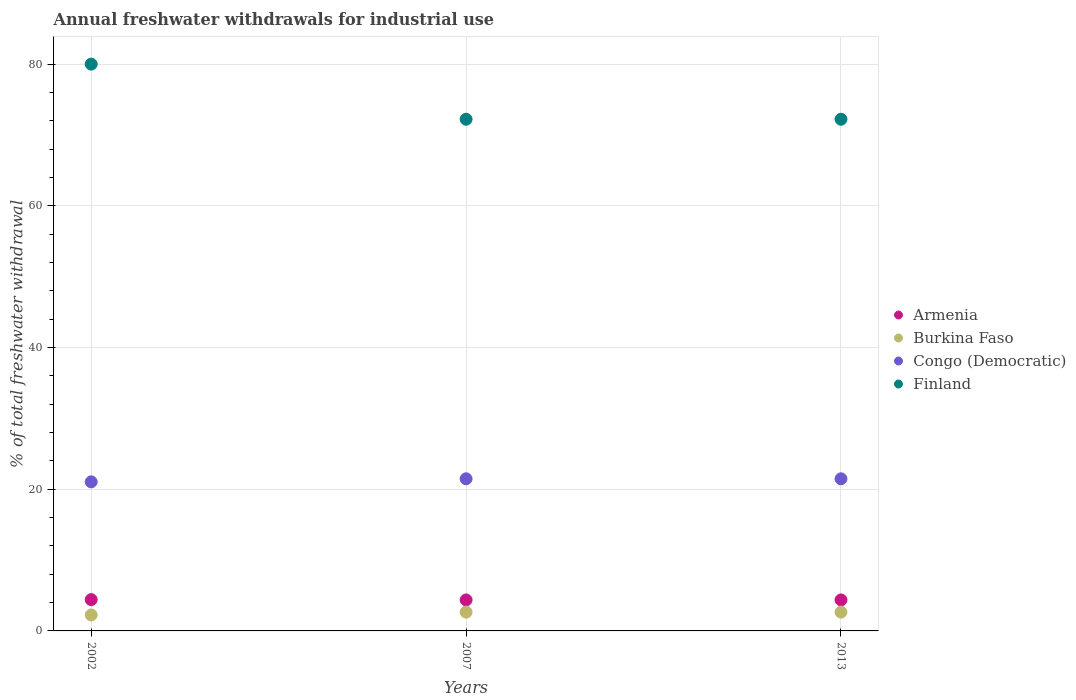How many different coloured dotlines are there?
Your answer should be very brief. 4. Is the number of dotlines equal to the number of legend labels?
Your answer should be very brief. Yes. What is the total annual withdrawals from freshwater in Burkina Faso in 2013?
Make the answer very short. 2.65. Across all years, what is the minimum total annual withdrawals from freshwater in Burkina Faso?
Give a very brief answer. 2.25. In which year was the total annual withdrawals from freshwater in Congo (Democratic) minimum?
Provide a short and direct response. 2002. What is the total total annual withdrawals from freshwater in Finland in the graph?
Your answer should be compact. 224.44. What is the difference between the total annual withdrawals from freshwater in Burkina Faso in 2002 and that in 2007?
Offer a very short reply. -0.4. What is the difference between the total annual withdrawals from freshwater in Burkina Faso in 2002 and the total annual withdrawals from freshwater in Congo (Democratic) in 2013?
Provide a short and direct response. -19.22. What is the average total annual withdrawals from freshwater in Armenia per year?
Keep it short and to the point. 4.39. In the year 2013, what is the difference between the total annual withdrawals from freshwater in Armenia and total annual withdrawals from freshwater in Finland?
Offer a terse response. -67.85. In how many years, is the total annual withdrawals from freshwater in Burkina Faso greater than 12 %?
Keep it short and to the point. 0. What is the ratio of the total annual withdrawals from freshwater in Finland in 2002 to that in 2007?
Provide a short and direct response. 1.11. Is the total annual withdrawals from freshwater in Congo (Democratic) in 2002 less than that in 2013?
Keep it short and to the point. Yes. Is the difference between the total annual withdrawals from freshwater in Armenia in 2002 and 2013 greater than the difference between the total annual withdrawals from freshwater in Finland in 2002 and 2013?
Provide a succinct answer. No. What is the difference between the highest and the second highest total annual withdrawals from freshwater in Armenia?
Offer a very short reply. 0.05. What is the difference between the highest and the lowest total annual withdrawals from freshwater in Congo (Democratic)?
Offer a very short reply. 0.43. Does the total annual withdrawals from freshwater in Armenia monotonically increase over the years?
Offer a terse response. No. Is the total annual withdrawals from freshwater in Armenia strictly greater than the total annual withdrawals from freshwater in Burkina Faso over the years?
Provide a succinct answer. Yes. How many dotlines are there?
Give a very brief answer. 4. How many years are there in the graph?
Provide a succinct answer. 3. Does the graph contain grids?
Offer a very short reply. Yes. Where does the legend appear in the graph?
Provide a succinct answer. Center right. How are the legend labels stacked?
Provide a succinct answer. Vertical. What is the title of the graph?
Make the answer very short. Annual freshwater withdrawals for industrial use. What is the label or title of the Y-axis?
Provide a short and direct response. % of total freshwater withdrawal. What is the % of total freshwater withdrawal of Armenia in 2002?
Ensure brevity in your answer.  4.42. What is the % of total freshwater withdrawal of Burkina Faso in 2002?
Make the answer very short. 2.25. What is the % of total freshwater withdrawal in Congo (Democratic) in 2002?
Provide a succinct answer. 21.04. What is the % of total freshwater withdrawal of Finland in 2002?
Ensure brevity in your answer.  80. What is the % of total freshwater withdrawal in Armenia in 2007?
Make the answer very short. 4.37. What is the % of total freshwater withdrawal in Burkina Faso in 2007?
Ensure brevity in your answer.  2.65. What is the % of total freshwater withdrawal in Congo (Democratic) in 2007?
Provide a succinct answer. 21.47. What is the % of total freshwater withdrawal in Finland in 2007?
Keep it short and to the point. 72.22. What is the % of total freshwater withdrawal of Armenia in 2013?
Keep it short and to the point. 4.37. What is the % of total freshwater withdrawal of Burkina Faso in 2013?
Your answer should be very brief. 2.65. What is the % of total freshwater withdrawal of Congo (Democratic) in 2013?
Your answer should be very brief. 21.47. What is the % of total freshwater withdrawal in Finland in 2013?
Offer a very short reply. 72.22. Across all years, what is the maximum % of total freshwater withdrawal of Armenia?
Ensure brevity in your answer.  4.42. Across all years, what is the maximum % of total freshwater withdrawal in Burkina Faso?
Make the answer very short. 2.65. Across all years, what is the maximum % of total freshwater withdrawal of Congo (Democratic)?
Keep it short and to the point. 21.47. Across all years, what is the minimum % of total freshwater withdrawal in Armenia?
Your answer should be compact. 4.37. Across all years, what is the minimum % of total freshwater withdrawal of Burkina Faso?
Provide a short and direct response. 2.25. Across all years, what is the minimum % of total freshwater withdrawal in Congo (Democratic)?
Your answer should be compact. 21.04. Across all years, what is the minimum % of total freshwater withdrawal of Finland?
Your answer should be very brief. 72.22. What is the total % of total freshwater withdrawal in Armenia in the graph?
Keep it short and to the point. 13.17. What is the total % of total freshwater withdrawal of Burkina Faso in the graph?
Offer a very short reply. 7.56. What is the total % of total freshwater withdrawal of Congo (Democratic) in the graph?
Ensure brevity in your answer.  63.98. What is the total % of total freshwater withdrawal in Finland in the graph?
Ensure brevity in your answer.  224.44. What is the difference between the % of total freshwater withdrawal of Armenia in 2002 and that in 2007?
Your response must be concise. 0.05. What is the difference between the % of total freshwater withdrawal of Burkina Faso in 2002 and that in 2007?
Ensure brevity in your answer.  -0.4. What is the difference between the % of total freshwater withdrawal in Congo (Democratic) in 2002 and that in 2007?
Offer a terse response. -0.43. What is the difference between the % of total freshwater withdrawal of Finland in 2002 and that in 2007?
Provide a succinct answer. 7.78. What is the difference between the % of total freshwater withdrawal in Armenia in 2002 and that in 2013?
Your answer should be very brief. 0.05. What is the difference between the % of total freshwater withdrawal in Burkina Faso in 2002 and that in 2013?
Your answer should be very brief. -0.4. What is the difference between the % of total freshwater withdrawal of Congo (Democratic) in 2002 and that in 2013?
Keep it short and to the point. -0.43. What is the difference between the % of total freshwater withdrawal in Finland in 2002 and that in 2013?
Give a very brief answer. 7.78. What is the difference between the % of total freshwater withdrawal in Armenia in 2007 and that in 2013?
Offer a very short reply. 0. What is the difference between the % of total freshwater withdrawal of Burkina Faso in 2007 and that in 2013?
Give a very brief answer. 0. What is the difference between the % of total freshwater withdrawal in Armenia in 2002 and the % of total freshwater withdrawal in Burkina Faso in 2007?
Your response must be concise. 1.77. What is the difference between the % of total freshwater withdrawal of Armenia in 2002 and the % of total freshwater withdrawal of Congo (Democratic) in 2007?
Keep it short and to the point. -17.05. What is the difference between the % of total freshwater withdrawal in Armenia in 2002 and the % of total freshwater withdrawal in Finland in 2007?
Ensure brevity in your answer.  -67.8. What is the difference between the % of total freshwater withdrawal of Burkina Faso in 2002 and the % of total freshwater withdrawal of Congo (Democratic) in 2007?
Offer a very short reply. -19.22. What is the difference between the % of total freshwater withdrawal of Burkina Faso in 2002 and the % of total freshwater withdrawal of Finland in 2007?
Provide a succinct answer. -69.97. What is the difference between the % of total freshwater withdrawal in Congo (Democratic) in 2002 and the % of total freshwater withdrawal in Finland in 2007?
Your answer should be very brief. -51.18. What is the difference between the % of total freshwater withdrawal of Armenia in 2002 and the % of total freshwater withdrawal of Burkina Faso in 2013?
Provide a succinct answer. 1.77. What is the difference between the % of total freshwater withdrawal of Armenia in 2002 and the % of total freshwater withdrawal of Congo (Democratic) in 2013?
Your answer should be compact. -17.05. What is the difference between the % of total freshwater withdrawal of Armenia in 2002 and the % of total freshwater withdrawal of Finland in 2013?
Keep it short and to the point. -67.8. What is the difference between the % of total freshwater withdrawal in Burkina Faso in 2002 and the % of total freshwater withdrawal in Congo (Democratic) in 2013?
Provide a succinct answer. -19.22. What is the difference between the % of total freshwater withdrawal in Burkina Faso in 2002 and the % of total freshwater withdrawal in Finland in 2013?
Provide a succinct answer. -69.97. What is the difference between the % of total freshwater withdrawal in Congo (Democratic) in 2002 and the % of total freshwater withdrawal in Finland in 2013?
Give a very brief answer. -51.18. What is the difference between the % of total freshwater withdrawal in Armenia in 2007 and the % of total freshwater withdrawal in Burkina Faso in 2013?
Ensure brevity in your answer.  1.72. What is the difference between the % of total freshwater withdrawal of Armenia in 2007 and the % of total freshwater withdrawal of Congo (Democratic) in 2013?
Offer a terse response. -17.1. What is the difference between the % of total freshwater withdrawal of Armenia in 2007 and the % of total freshwater withdrawal of Finland in 2013?
Ensure brevity in your answer.  -67.85. What is the difference between the % of total freshwater withdrawal in Burkina Faso in 2007 and the % of total freshwater withdrawal in Congo (Democratic) in 2013?
Offer a terse response. -18.82. What is the difference between the % of total freshwater withdrawal in Burkina Faso in 2007 and the % of total freshwater withdrawal in Finland in 2013?
Give a very brief answer. -69.57. What is the difference between the % of total freshwater withdrawal of Congo (Democratic) in 2007 and the % of total freshwater withdrawal of Finland in 2013?
Your response must be concise. -50.75. What is the average % of total freshwater withdrawal in Armenia per year?
Provide a succinct answer. 4.39. What is the average % of total freshwater withdrawal of Burkina Faso per year?
Your response must be concise. 2.52. What is the average % of total freshwater withdrawal of Congo (Democratic) per year?
Ensure brevity in your answer.  21.33. What is the average % of total freshwater withdrawal of Finland per year?
Offer a very short reply. 74.81. In the year 2002, what is the difference between the % of total freshwater withdrawal of Armenia and % of total freshwater withdrawal of Burkina Faso?
Provide a succinct answer. 2.17. In the year 2002, what is the difference between the % of total freshwater withdrawal in Armenia and % of total freshwater withdrawal in Congo (Democratic)?
Your answer should be compact. -16.62. In the year 2002, what is the difference between the % of total freshwater withdrawal in Armenia and % of total freshwater withdrawal in Finland?
Your answer should be very brief. -75.58. In the year 2002, what is the difference between the % of total freshwater withdrawal in Burkina Faso and % of total freshwater withdrawal in Congo (Democratic)?
Provide a succinct answer. -18.79. In the year 2002, what is the difference between the % of total freshwater withdrawal of Burkina Faso and % of total freshwater withdrawal of Finland?
Your answer should be very brief. -77.75. In the year 2002, what is the difference between the % of total freshwater withdrawal of Congo (Democratic) and % of total freshwater withdrawal of Finland?
Provide a succinct answer. -58.96. In the year 2007, what is the difference between the % of total freshwater withdrawal in Armenia and % of total freshwater withdrawal in Burkina Faso?
Provide a short and direct response. 1.72. In the year 2007, what is the difference between the % of total freshwater withdrawal of Armenia and % of total freshwater withdrawal of Congo (Democratic)?
Provide a succinct answer. -17.1. In the year 2007, what is the difference between the % of total freshwater withdrawal of Armenia and % of total freshwater withdrawal of Finland?
Ensure brevity in your answer.  -67.85. In the year 2007, what is the difference between the % of total freshwater withdrawal of Burkina Faso and % of total freshwater withdrawal of Congo (Democratic)?
Offer a very short reply. -18.82. In the year 2007, what is the difference between the % of total freshwater withdrawal in Burkina Faso and % of total freshwater withdrawal in Finland?
Offer a terse response. -69.57. In the year 2007, what is the difference between the % of total freshwater withdrawal in Congo (Democratic) and % of total freshwater withdrawal in Finland?
Make the answer very short. -50.75. In the year 2013, what is the difference between the % of total freshwater withdrawal of Armenia and % of total freshwater withdrawal of Burkina Faso?
Provide a succinct answer. 1.72. In the year 2013, what is the difference between the % of total freshwater withdrawal in Armenia and % of total freshwater withdrawal in Congo (Democratic)?
Your answer should be compact. -17.1. In the year 2013, what is the difference between the % of total freshwater withdrawal of Armenia and % of total freshwater withdrawal of Finland?
Offer a very short reply. -67.85. In the year 2013, what is the difference between the % of total freshwater withdrawal of Burkina Faso and % of total freshwater withdrawal of Congo (Democratic)?
Ensure brevity in your answer.  -18.82. In the year 2013, what is the difference between the % of total freshwater withdrawal of Burkina Faso and % of total freshwater withdrawal of Finland?
Your answer should be very brief. -69.57. In the year 2013, what is the difference between the % of total freshwater withdrawal of Congo (Democratic) and % of total freshwater withdrawal of Finland?
Offer a terse response. -50.75. What is the ratio of the % of total freshwater withdrawal in Armenia in 2002 to that in 2007?
Offer a very short reply. 1.01. What is the ratio of the % of total freshwater withdrawal of Burkina Faso in 2002 to that in 2007?
Keep it short and to the point. 0.85. What is the ratio of the % of total freshwater withdrawal in Congo (Democratic) in 2002 to that in 2007?
Provide a short and direct response. 0.98. What is the ratio of the % of total freshwater withdrawal in Finland in 2002 to that in 2007?
Provide a short and direct response. 1.11. What is the ratio of the % of total freshwater withdrawal in Armenia in 2002 to that in 2013?
Your answer should be very brief. 1.01. What is the ratio of the % of total freshwater withdrawal of Burkina Faso in 2002 to that in 2013?
Offer a terse response. 0.85. What is the ratio of the % of total freshwater withdrawal in Congo (Democratic) in 2002 to that in 2013?
Offer a terse response. 0.98. What is the ratio of the % of total freshwater withdrawal of Finland in 2002 to that in 2013?
Make the answer very short. 1.11. What is the ratio of the % of total freshwater withdrawal in Burkina Faso in 2007 to that in 2013?
Provide a short and direct response. 1. What is the ratio of the % of total freshwater withdrawal in Finland in 2007 to that in 2013?
Your answer should be very brief. 1. What is the difference between the highest and the second highest % of total freshwater withdrawal in Armenia?
Your response must be concise. 0.05. What is the difference between the highest and the second highest % of total freshwater withdrawal of Finland?
Offer a terse response. 7.78. What is the difference between the highest and the lowest % of total freshwater withdrawal in Armenia?
Give a very brief answer. 0.05. What is the difference between the highest and the lowest % of total freshwater withdrawal in Burkina Faso?
Your response must be concise. 0.4. What is the difference between the highest and the lowest % of total freshwater withdrawal in Congo (Democratic)?
Provide a short and direct response. 0.43. What is the difference between the highest and the lowest % of total freshwater withdrawal of Finland?
Your response must be concise. 7.78. 